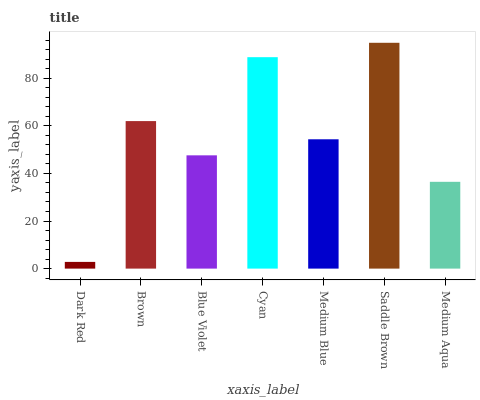Is Dark Red the minimum?
Answer yes or no. Yes. Is Saddle Brown the maximum?
Answer yes or no. Yes. Is Brown the minimum?
Answer yes or no. No. Is Brown the maximum?
Answer yes or no. No. Is Brown greater than Dark Red?
Answer yes or no. Yes. Is Dark Red less than Brown?
Answer yes or no. Yes. Is Dark Red greater than Brown?
Answer yes or no. No. Is Brown less than Dark Red?
Answer yes or no. No. Is Medium Blue the high median?
Answer yes or no. Yes. Is Medium Blue the low median?
Answer yes or no. Yes. Is Dark Red the high median?
Answer yes or no. No. Is Brown the low median?
Answer yes or no. No. 